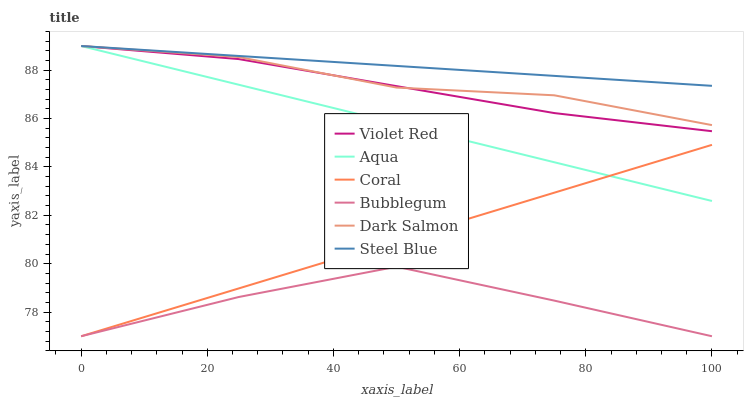Does Bubblegum have the minimum area under the curve?
Answer yes or no. Yes. Does Coral have the minimum area under the curve?
Answer yes or no. No. Does Coral have the maximum area under the curve?
Answer yes or no. No. Is Bubblegum the roughest?
Answer yes or no. Yes. Is Coral the smoothest?
Answer yes or no. No. Is Coral the roughest?
Answer yes or no. No. Does Aqua have the lowest value?
Answer yes or no. No. Does Coral have the highest value?
Answer yes or no. No. Is Coral less than Dark Salmon?
Answer yes or no. Yes. Is Dark Salmon greater than Bubblegum?
Answer yes or no. Yes. Does Coral intersect Dark Salmon?
Answer yes or no. No. 